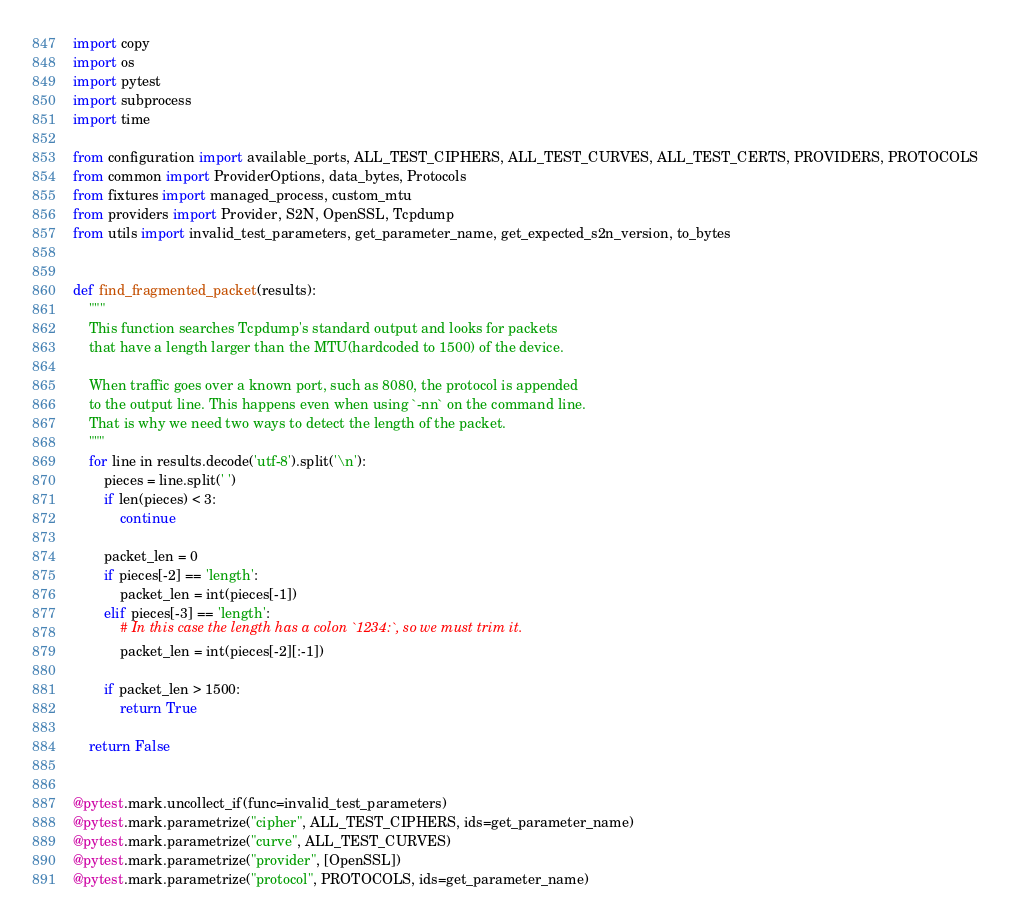<code> <loc_0><loc_0><loc_500><loc_500><_Python_>import copy
import os
import pytest
import subprocess
import time

from configuration import available_ports, ALL_TEST_CIPHERS, ALL_TEST_CURVES, ALL_TEST_CERTS, PROVIDERS, PROTOCOLS
from common import ProviderOptions, data_bytes, Protocols
from fixtures import managed_process, custom_mtu
from providers import Provider, S2N, OpenSSL, Tcpdump
from utils import invalid_test_parameters, get_parameter_name, get_expected_s2n_version, to_bytes


def find_fragmented_packet(results):
    """
    This function searches Tcpdump's standard output and looks for packets
    that have a length larger than the MTU(hardcoded to 1500) of the device.

    When traffic goes over a known port, such as 8080, the protocol is appended
    to the output line. This happens even when using `-nn` on the command line.
    That is why we need two ways to detect the length of the packet.
    """
    for line in results.decode('utf-8').split('\n'):
        pieces = line.split(' ')
        if len(pieces) < 3:
            continue

        packet_len = 0
        if pieces[-2] == 'length':
            packet_len = int(pieces[-1])
        elif pieces[-3] == 'length':
            # In this case the length has a colon `1234:`, so we must trim it.
            packet_len = int(pieces[-2][:-1])

        if packet_len > 1500:
            return True

    return False


@pytest.mark.uncollect_if(func=invalid_test_parameters)
@pytest.mark.parametrize("cipher", ALL_TEST_CIPHERS, ids=get_parameter_name)
@pytest.mark.parametrize("curve", ALL_TEST_CURVES)
@pytest.mark.parametrize("provider", [OpenSSL])
@pytest.mark.parametrize("protocol", PROTOCOLS, ids=get_parameter_name)</code> 